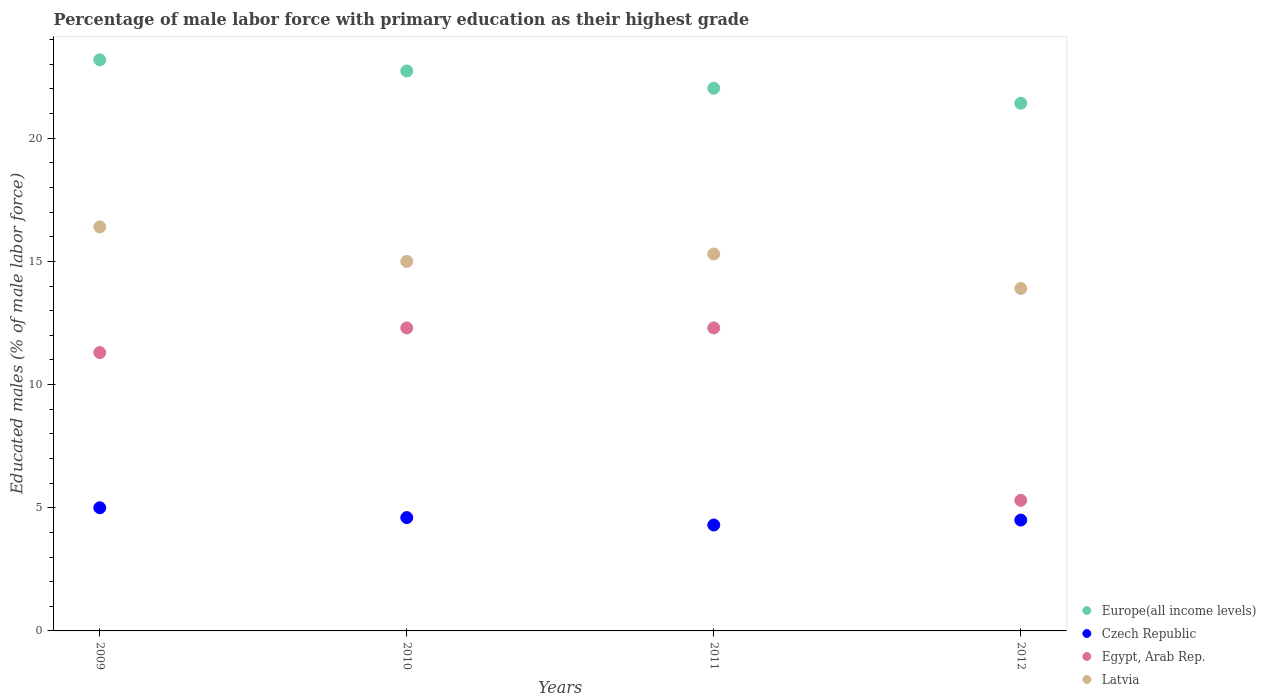How many different coloured dotlines are there?
Ensure brevity in your answer.  4. What is the percentage of male labor force with primary education in Egypt, Arab Rep. in 2012?
Provide a short and direct response. 5.3. Across all years, what is the maximum percentage of male labor force with primary education in Egypt, Arab Rep.?
Offer a very short reply. 12.3. Across all years, what is the minimum percentage of male labor force with primary education in Europe(all income levels)?
Provide a succinct answer. 21.42. In which year was the percentage of male labor force with primary education in Egypt, Arab Rep. minimum?
Offer a very short reply. 2012. What is the total percentage of male labor force with primary education in Europe(all income levels) in the graph?
Your answer should be very brief. 89.36. What is the difference between the percentage of male labor force with primary education in Europe(all income levels) in 2009 and that in 2011?
Provide a succinct answer. 1.15. What is the difference between the percentage of male labor force with primary education in Egypt, Arab Rep. in 2011 and the percentage of male labor force with primary education in Latvia in 2009?
Offer a very short reply. -4.1. What is the average percentage of male labor force with primary education in Czech Republic per year?
Give a very brief answer. 4.6. In the year 2012, what is the difference between the percentage of male labor force with primary education in Egypt, Arab Rep. and percentage of male labor force with primary education in Latvia?
Make the answer very short. -8.6. What is the ratio of the percentage of male labor force with primary education in Europe(all income levels) in 2011 to that in 2012?
Give a very brief answer. 1.03. Is the percentage of male labor force with primary education in Europe(all income levels) in 2011 less than that in 2012?
Your answer should be very brief. No. Is the difference between the percentage of male labor force with primary education in Egypt, Arab Rep. in 2010 and 2011 greater than the difference between the percentage of male labor force with primary education in Latvia in 2010 and 2011?
Ensure brevity in your answer.  Yes. What is the difference between the highest and the lowest percentage of male labor force with primary education in Czech Republic?
Ensure brevity in your answer.  0.7. In how many years, is the percentage of male labor force with primary education in Latvia greater than the average percentage of male labor force with primary education in Latvia taken over all years?
Offer a terse response. 2. Is the sum of the percentage of male labor force with primary education in Czech Republic in 2011 and 2012 greater than the maximum percentage of male labor force with primary education in Egypt, Arab Rep. across all years?
Your answer should be very brief. No. Is it the case that in every year, the sum of the percentage of male labor force with primary education in Europe(all income levels) and percentage of male labor force with primary education in Czech Republic  is greater than the percentage of male labor force with primary education in Latvia?
Offer a terse response. Yes. Is the percentage of male labor force with primary education in Europe(all income levels) strictly less than the percentage of male labor force with primary education in Latvia over the years?
Offer a terse response. No. How many years are there in the graph?
Make the answer very short. 4. What is the difference between two consecutive major ticks on the Y-axis?
Your answer should be very brief. 5. Are the values on the major ticks of Y-axis written in scientific E-notation?
Offer a terse response. No. What is the title of the graph?
Your answer should be very brief. Percentage of male labor force with primary education as their highest grade. What is the label or title of the X-axis?
Your answer should be compact. Years. What is the label or title of the Y-axis?
Keep it short and to the point. Educated males (% of male labor force). What is the Educated males (% of male labor force) of Europe(all income levels) in 2009?
Provide a succinct answer. 23.18. What is the Educated males (% of male labor force) in Egypt, Arab Rep. in 2009?
Provide a short and direct response. 11.3. What is the Educated males (% of male labor force) in Latvia in 2009?
Your answer should be very brief. 16.4. What is the Educated males (% of male labor force) of Europe(all income levels) in 2010?
Give a very brief answer. 22.73. What is the Educated males (% of male labor force) in Czech Republic in 2010?
Your answer should be compact. 4.6. What is the Educated males (% of male labor force) in Egypt, Arab Rep. in 2010?
Offer a very short reply. 12.3. What is the Educated males (% of male labor force) in Latvia in 2010?
Your answer should be very brief. 15. What is the Educated males (% of male labor force) of Europe(all income levels) in 2011?
Provide a succinct answer. 22.03. What is the Educated males (% of male labor force) of Czech Republic in 2011?
Offer a very short reply. 4.3. What is the Educated males (% of male labor force) of Egypt, Arab Rep. in 2011?
Your response must be concise. 12.3. What is the Educated males (% of male labor force) of Latvia in 2011?
Provide a short and direct response. 15.3. What is the Educated males (% of male labor force) in Europe(all income levels) in 2012?
Your response must be concise. 21.42. What is the Educated males (% of male labor force) of Egypt, Arab Rep. in 2012?
Ensure brevity in your answer.  5.3. What is the Educated males (% of male labor force) of Latvia in 2012?
Keep it short and to the point. 13.9. Across all years, what is the maximum Educated males (% of male labor force) of Europe(all income levels)?
Offer a terse response. 23.18. Across all years, what is the maximum Educated males (% of male labor force) in Czech Republic?
Your response must be concise. 5. Across all years, what is the maximum Educated males (% of male labor force) of Egypt, Arab Rep.?
Offer a terse response. 12.3. Across all years, what is the maximum Educated males (% of male labor force) in Latvia?
Offer a very short reply. 16.4. Across all years, what is the minimum Educated males (% of male labor force) in Europe(all income levels)?
Your answer should be very brief. 21.42. Across all years, what is the minimum Educated males (% of male labor force) of Czech Republic?
Your answer should be very brief. 4.3. Across all years, what is the minimum Educated males (% of male labor force) in Egypt, Arab Rep.?
Make the answer very short. 5.3. Across all years, what is the minimum Educated males (% of male labor force) of Latvia?
Your response must be concise. 13.9. What is the total Educated males (% of male labor force) of Europe(all income levels) in the graph?
Make the answer very short. 89.36. What is the total Educated males (% of male labor force) in Czech Republic in the graph?
Make the answer very short. 18.4. What is the total Educated males (% of male labor force) in Egypt, Arab Rep. in the graph?
Give a very brief answer. 41.2. What is the total Educated males (% of male labor force) of Latvia in the graph?
Your answer should be compact. 60.6. What is the difference between the Educated males (% of male labor force) in Europe(all income levels) in 2009 and that in 2010?
Ensure brevity in your answer.  0.45. What is the difference between the Educated males (% of male labor force) of Egypt, Arab Rep. in 2009 and that in 2010?
Provide a short and direct response. -1. What is the difference between the Educated males (% of male labor force) of Latvia in 2009 and that in 2010?
Provide a succinct answer. 1.4. What is the difference between the Educated males (% of male labor force) of Europe(all income levels) in 2009 and that in 2011?
Give a very brief answer. 1.15. What is the difference between the Educated males (% of male labor force) of Europe(all income levels) in 2009 and that in 2012?
Provide a short and direct response. 1.76. What is the difference between the Educated males (% of male labor force) of Egypt, Arab Rep. in 2009 and that in 2012?
Your response must be concise. 6. What is the difference between the Educated males (% of male labor force) in Latvia in 2009 and that in 2012?
Give a very brief answer. 2.5. What is the difference between the Educated males (% of male labor force) of Europe(all income levels) in 2010 and that in 2011?
Provide a short and direct response. 0.7. What is the difference between the Educated males (% of male labor force) in Czech Republic in 2010 and that in 2011?
Provide a succinct answer. 0.3. What is the difference between the Educated males (% of male labor force) of Europe(all income levels) in 2010 and that in 2012?
Your answer should be compact. 1.31. What is the difference between the Educated males (% of male labor force) of Czech Republic in 2010 and that in 2012?
Your answer should be compact. 0.1. What is the difference between the Educated males (% of male labor force) of Europe(all income levels) in 2011 and that in 2012?
Your answer should be very brief. 0.61. What is the difference between the Educated males (% of male labor force) of Europe(all income levels) in 2009 and the Educated males (% of male labor force) of Czech Republic in 2010?
Provide a short and direct response. 18.58. What is the difference between the Educated males (% of male labor force) in Europe(all income levels) in 2009 and the Educated males (% of male labor force) in Egypt, Arab Rep. in 2010?
Offer a terse response. 10.88. What is the difference between the Educated males (% of male labor force) of Europe(all income levels) in 2009 and the Educated males (% of male labor force) of Latvia in 2010?
Ensure brevity in your answer.  8.18. What is the difference between the Educated males (% of male labor force) of Czech Republic in 2009 and the Educated males (% of male labor force) of Egypt, Arab Rep. in 2010?
Provide a succinct answer. -7.3. What is the difference between the Educated males (% of male labor force) in Egypt, Arab Rep. in 2009 and the Educated males (% of male labor force) in Latvia in 2010?
Your answer should be compact. -3.7. What is the difference between the Educated males (% of male labor force) in Europe(all income levels) in 2009 and the Educated males (% of male labor force) in Czech Republic in 2011?
Your response must be concise. 18.88. What is the difference between the Educated males (% of male labor force) in Europe(all income levels) in 2009 and the Educated males (% of male labor force) in Egypt, Arab Rep. in 2011?
Make the answer very short. 10.88. What is the difference between the Educated males (% of male labor force) in Europe(all income levels) in 2009 and the Educated males (% of male labor force) in Latvia in 2011?
Offer a terse response. 7.88. What is the difference between the Educated males (% of male labor force) of Czech Republic in 2009 and the Educated males (% of male labor force) of Egypt, Arab Rep. in 2011?
Your answer should be very brief. -7.3. What is the difference between the Educated males (% of male labor force) in Europe(all income levels) in 2009 and the Educated males (% of male labor force) in Czech Republic in 2012?
Give a very brief answer. 18.68. What is the difference between the Educated males (% of male labor force) of Europe(all income levels) in 2009 and the Educated males (% of male labor force) of Egypt, Arab Rep. in 2012?
Ensure brevity in your answer.  17.88. What is the difference between the Educated males (% of male labor force) in Europe(all income levels) in 2009 and the Educated males (% of male labor force) in Latvia in 2012?
Your answer should be very brief. 9.28. What is the difference between the Educated males (% of male labor force) in Europe(all income levels) in 2010 and the Educated males (% of male labor force) in Czech Republic in 2011?
Your answer should be very brief. 18.43. What is the difference between the Educated males (% of male labor force) in Europe(all income levels) in 2010 and the Educated males (% of male labor force) in Egypt, Arab Rep. in 2011?
Give a very brief answer. 10.43. What is the difference between the Educated males (% of male labor force) of Europe(all income levels) in 2010 and the Educated males (% of male labor force) of Latvia in 2011?
Give a very brief answer. 7.43. What is the difference between the Educated males (% of male labor force) of Czech Republic in 2010 and the Educated males (% of male labor force) of Egypt, Arab Rep. in 2011?
Give a very brief answer. -7.7. What is the difference between the Educated males (% of male labor force) of Europe(all income levels) in 2010 and the Educated males (% of male labor force) of Czech Republic in 2012?
Offer a terse response. 18.23. What is the difference between the Educated males (% of male labor force) in Europe(all income levels) in 2010 and the Educated males (% of male labor force) in Egypt, Arab Rep. in 2012?
Make the answer very short. 17.43. What is the difference between the Educated males (% of male labor force) in Europe(all income levels) in 2010 and the Educated males (% of male labor force) in Latvia in 2012?
Provide a succinct answer. 8.83. What is the difference between the Educated males (% of male labor force) of Czech Republic in 2010 and the Educated males (% of male labor force) of Latvia in 2012?
Your answer should be compact. -9.3. What is the difference between the Educated males (% of male labor force) of Europe(all income levels) in 2011 and the Educated males (% of male labor force) of Czech Republic in 2012?
Make the answer very short. 17.53. What is the difference between the Educated males (% of male labor force) in Europe(all income levels) in 2011 and the Educated males (% of male labor force) in Egypt, Arab Rep. in 2012?
Offer a very short reply. 16.73. What is the difference between the Educated males (% of male labor force) in Europe(all income levels) in 2011 and the Educated males (% of male labor force) in Latvia in 2012?
Ensure brevity in your answer.  8.13. What is the difference between the Educated males (% of male labor force) of Czech Republic in 2011 and the Educated males (% of male labor force) of Egypt, Arab Rep. in 2012?
Make the answer very short. -1. What is the difference between the Educated males (% of male labor force) in Egypt, Arab Rep. in 2011 and the Educated males (% of male labor force) in Latvia in 2012?
Provide a short and direct response. -1.6. What is the average Educated males (% of male labor force) of Europe(all income levels) per year?
Your answer should be very brief. 22.34. What is the average Educated males (% of male labor force) in Latvia per year?
Make the answer very short. 15.15. In the year 2009, what is the difference between the Educated males (% of male labor force) in Europe(all income levels) and Educated males (% of male labor force) in Czech Republic?
Keep it short and to the point. 18.18. In the year 2009, what is the difference between the Educated males (% of male labor force) in Europe(all income levels) and Educated males (% of male labor force) in Egypt, Arab Rep.?
Provide a short and direct response. 11.88. In the year 2009, what is the difference between the Educated males (% of male labor force) in Europe(all income levels) and Educated males (% of male labor force) in Latvia?
Offer a terse response. 6.78. In the year 2010, what is the difference between the Educated males (% of male labor force) in Europe(all income levels) and Educated males (% of male labor force) in Czech Republic?
Your answer should be very brief. 18.13. In the year 2010, what is the difference between the Educated males (% of male labor force) in Europe(all income levels) and Educated males (% of male labor force) in Egypt, Arab Rep.?
Your answer should be compact. 10.43. In the year 2010, what is the difference between the Educated males (% of male labor force) in Europe(all income levels) and Educated males (% of male labor force) in Latvia?
Make the answer very short. 7.73. In the year 2010, what is the difference between the Educated males (% of male labor force) in Czech Republic and Educated males (% of male labor force) in Latvia?
Provide a succinct answer. -10.4. In the year 2010, what is the difference between the Educated males (% of male labor force) in Egypt, Arab Rep. and Educated males (% of male labor force) in Latvia?
Your response must be concise. -2.7. In the year 2011, what is the difference between the Educated males (% of male labor force) in Europe(all income levels) and Educated males (% of male labor force) in Czech Republic?
Give a very brief answer. 17.73. In the year 2011, what is the difference between the Educated males (% of male labor force) in Europe(all income levels) and Educated males (% of male labor force) in Egypt, Arab Rep.?
Keep it short and to the point. 9.73. In the year 2011, what is the difference between the Educated males (% of male labor force) in Europe(all income levels) and Educated males (% of male labor force) in Latvia?
Keep it short and to the point. 6.73. In the year 2012, what is the difference between the Educated males (% of male labor force) of Europe(all income levels) and Educated males (% of male labor force) of Czech Republic?
Your answer should be compact. 16.92. In the year 2012, what is the difference between the Educated males (% of male labor force) of Europe(all income levels) and Educated males (% of male labor force) of Egypt, Arab Rep.?
Make the answer very short. 16.12. In the year 2012, what is the difference between the Educated males (% of male labor force) in Europe(all income levels) and Educated males (% of male labor force) in Latvia?
Ensure brevity in your answer.  7.52. In the year 2012, what is the difference between the Educated males (% of male labor force) of Czech Republic and Educated males (% of male labor force) of Egypt, Arab Rep.?
Ensure brevity in your answer.  -0.8. In the year 2012, what is the difference between the Educated males (% of male labor force) of Czech Republic and Educated males (% of male labor force) of Latvia?
Give a very brief answer. -9.4. In the year 2012, what is the difference between the Educated males (% of male labor force) in Egypt, Arab Rep. and Educated males (% of male labor force) in Latvia?
Your answer should be compact. -8.6. What is the ratio of the Educated males (% of male labor force) of Europe(all income levels) in 2009 to that in 2010?
Ensure brevity in your answer.  1.02. What is the ratio of the Educated males (% of male labor force) in Czech Republic in 2009 to that in 2010?
Your answer should be very brief. 1.09. What is the ratio of the Educated males (% of male labor force) of Egypt, Arab Rep. in 2009 to that in 2010?
Your answer should be very brief. 0.92. What is the ratio of the Educated males (% of male labor force) in Latvia in 2009 to that in 2010?
Keep it short and to the point. 1.09. What is the ratio of the Educated males (% of male labor force) of Europe(all income levels) in 2009 to that in 2011?
Your answer should be very brief. 1.05. What is the ratio of the Educated males (% of male labor force) in Czech Republic in 2009 to that in 2011?
Your answer should be very brief. 1.16. What is the ratio of the Educated males (% of male labor force) of Egypt, Arab Rep. in 2009 to that in 2011?
Offer a very short reply. 0.92. What is the ratio of the Educated males (% of male labor force) of Latvia in 2009 to that in 2011?
Give a very brief answer. 1.07. What is the ratio of the Educated males (% of male labor force) in Europe(all income levels) in 2009 to that in 2012?
Make the answer very short. 1.08. What is the ratio of the Educated males (% of male labor force) in Czech Republic in 2009 to that in 2012?
Keep it short and to the point. 1.11. What is the ratio of the Educated males (% of male labor force) of Egypt, Arab Rep. in 2009 to that in 2012?
Offer a very short reply. 2.13. What is the ratio of the Educated males (% of male labor force) of Latvia in 2009 to that in 2012?
Offer a terse response. 1.18. What is the ratio of the Educated males (% of male labor force) in Europe(all income levels) in 2010 to that in 2011?
Your answer should be very brief. 1.03. What is the ratio of the Educated males (% of male labor force) of Czech Republic in 2010 to that in 2011?
Give a very brief answer. 1.07. What is the ratio of the Educated males (% of male labor force) of Latvia in 2010 to that in 2011?
Your answer should be compact. 0.98. What is the ratio of the Educated males (% of male labor force) of Europe(all income levels) in 2010 to that in 2012?
Give a very brief answer. 1.06. What is the ratio of the Educated males (% of male labor force) in Czech Republic in 2010 to that in 2012?
Provide a short and direct response. 1.02. What is the ratio of the Educated males (% of male labor force) in Egypt, Arab Rep. in 2010 to that in 2012?
Offer a terse response. 2.32. What is the ratio of the Educated males (% of male labor force) of Latvia in 2010 to that in 2012?
Make the answer very short. 1.08. What is the ratio of the Educated males (% of male labor force) in Europe(all income levels) in 2011 to that in 2012?
Make the answer very short. 1.03. What is the ratio of the Educated males (% of male labor force) of Czech Republic in 2011 to that in 2012?
Give a very brief answer. 0.96. What is the ratio of the Educated males (% of male labor force) of Egypt, Arab Rep. in 2011 to that in 2012?
Keep it short and to the point. 2.32. What is the ratio of the Educated males (% of male labor force) in Latvia in 2011 to that in 2012?
Your answer should be very brief. 1.1. What is the difference between the highest and the second highest Educated males (% of male labor force) in Europe(all income levels)?
Provide a succinct answer. 0.45. What is the difference between the highest and the second highest Educated males (% of male labor force) in Egypt, Arab Rep.?
Offer a very short reply. 0. What is the difference between the highest and the second highest Educated males (% of male labor force) in Latvia?
Offer a terse response. 1.1. What is the difference between the highest and the lowest Educated males (% of male labor force) of Europe(all income levels)?
Provide a succinct answer. 1.76. What is the difference between the highest and the lowest Educated males (% of male labor force) in Czech Republic?
Give a very brief answer. 0.7. What is the difference between the highest and the lowest Educated males (% of male labor force) of Latvia?
Your response must be concise. 2.5. 